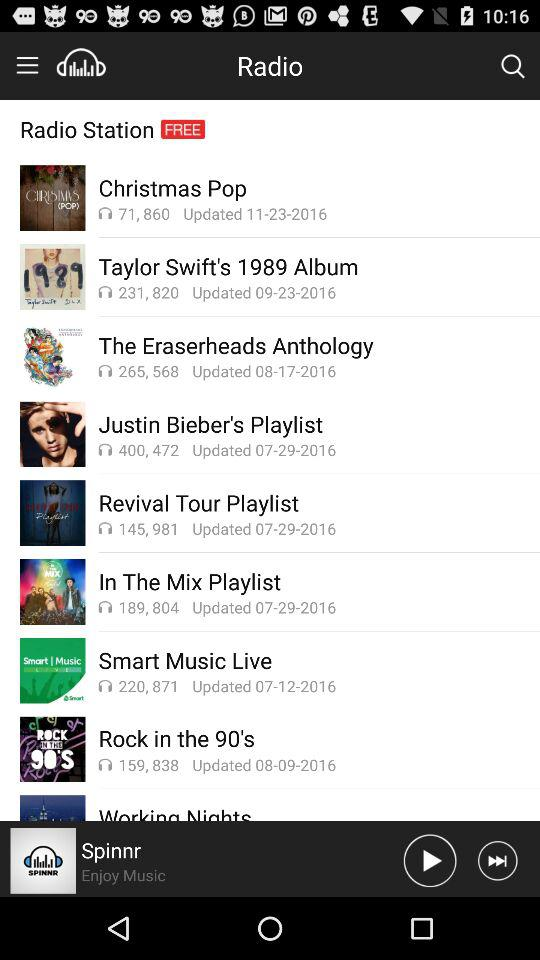When is the "Christmas Pop" song updated? The "Christmas Pop" song is updated on November 23, 2016. 